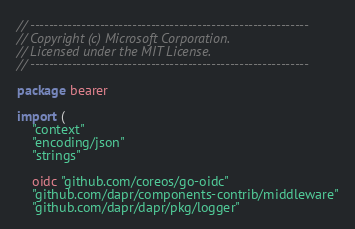Convert code to text. <code><loc_0><loc_0><loc_500><loc_500><_Go_>// ------------------------------------------------------------
// Copyright (c) Microsoft Corporation.
// Licensed under the MIT License.
// ------------------------------------------------------------

package bearer

import (
	"context"
	"encoding/json"
	"strings"

	oidc "github.com/coreos/go-oidc"
	"github.com/dapr/components-contrib/middleware"
	"github.com/dapr/dapr/pkg/logger"</code> 